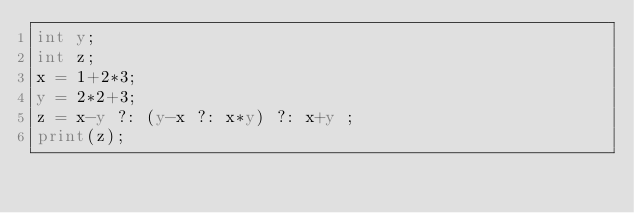Convert code to text. <code><loc_0><loc_0><loc_500><loc_500><_Perl_>int y;
int z;
x = 1+2*3; 
y = 2*2+3; 
z = x-y ?: (y-x ?: x*y) ?: x+y ;
print(z);
</code> 